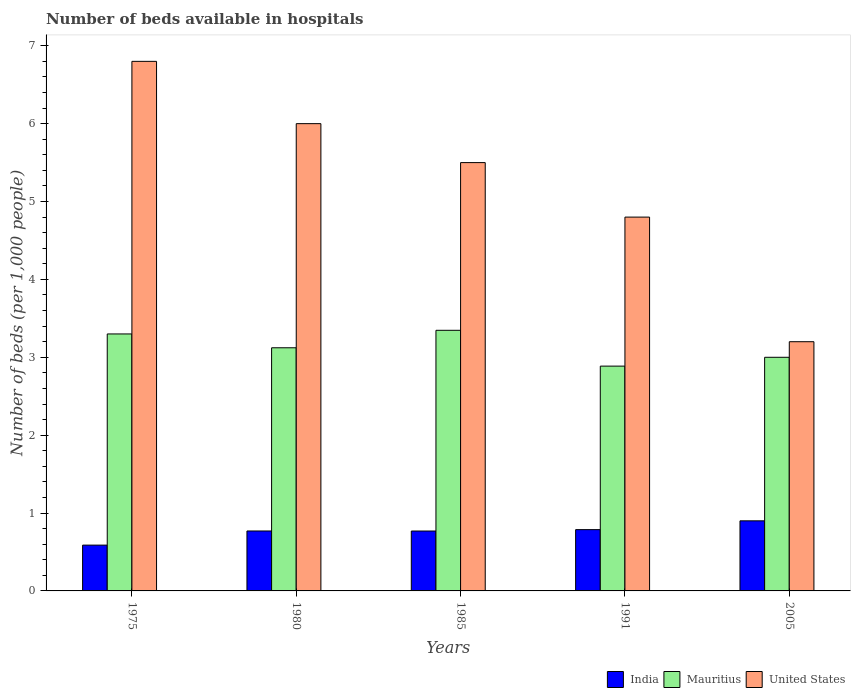How many different coloured bars are there?
Ensure brevity in your answer.  3. Are the number of bars on each tick of the X-axis equal?
Offer a terse response. Yes. How many bars are there on the 4th tick from the left?
Give a very brief answer. 3. How many bars are there on the 5th tick from the right?
Make the answer very short. 3. What is the label of the 1st group of bars from the left?
Provide a succinct answer. 1975. In how many cases, is the number of bars for a given year not equal to the number of legend labels?
Your answer should be compact. 0. Across all years, what is the maximum number of beds in the hospiatls of in United States?
Provide a short and direct response. 6.8. In which year was the number of beds in the hospiatls of in Mauritius maximum?
Ensure brevity in your answer.  1985. In which year was the number of beds in the hospiatls of in India minimum?
Your answer should be compact. 1975. What is the total number of beds in the hospiatls of in United States in the graph?
Offer a very short reply. 26.3. What is the difference between the number of beds in the hospiatls of in United States in 1985 and that in 1991?
Your response must be concise. 0.7. What is the difference between the number of beds in the hospiatls of in United States in 1991 and the number of beds in the hospiatls of in Mauritius in 1980?
Your response must be concise. 1.68. What is the average number of beds in the hospiatls of in India per year?
Keep it short and to the point. 0.76. In the year 1991, what is the difference between the number of beds in the hospiatls of in India and number of beds in the hospiatls of in Mauritius?
Provide a short and direct response. -2.1. What is the ratio of the number of beds in the hospiatls of in India in 1980 to that in 2005?
Give a very brief answer. 0.86. Is the number of beds in the hospiatls of in India in 1975 less than that in 2005?
Keep it short and to the point. Yes. Is the difference between the number of beds in the hospiatls of in India in 1991 and 2005 greater than the difference between the number of beds in the hospiatls of in Mauritius in 1991 and 2005?
Your response must be concise. Yes. What is the difference between the highest and the second highest number of beds in the hospiatls of in United States?
Your answer should be compact. 0.8. What is the difference between the highest and the lowest number of beds in the hospiatls of in India?
Keep it short and to the point. 0.31. In how many years, is the number of beds in the hospiatls of in India greater than the average number of beds in the hospiatls of in India taken over all years?
Your response must be concise. 4. What does the 3rd bar from the left in 1991 represents?
Provide a short and direct response. United States. What does the 2nd bar from the right in 1975 represents?
Provide a succinct answer. Mauritius. Is it the case that in every year, the sum of the number of beds in the hospiatls of in India and number of beds in the hospiatls of in Mauritius is greater than the number of beds in the hospiatls of in United States?
Your answer should be compact. No. How many bars are there?
Offer a very short reply. 15. What is the difference between two consecutive major ticks on the Y-axis?
Ensure brevity in your answer.  1. Where does the legend appear in the graph?
Offer a very short reply. Bottom right. How many legend labels are there?
Offer a terse response. 3. What is the title of the graph?
Your answer should be compact. Number of beds available in hospitals. Does "Guatemala" appear as one of the legend labels in the graph?
Provide a short and direct response. No. What is the label or title of the Y-axis?
Give a very brief answer. Number of beds (per 1,0 people). What is the Number of beds (per 1,000 people) of India in 1975?
Provide a succinct answer. 0.59. What is the Number of beds (per 1,000 people) in Mauritius in 1975?
Ensure brevity in your answer.  3.3. What is the Number of beds (per 1,000 people) in United States in 1975?
Your answer should be very brief. 6.8. What is the Number of beds (per 1,000 people) of India in 1980?
Make the answer very short. 0.77. What is the Number of beds (per 1,000 people) of Mauritius in 1980?
Offer a very short reply. 3.12. What is the Number of beds (per 1,000 people) in United States in 1980?
Your response must be concise. 6. What is the Number of beds (per 1,000 people) of India in 1985?
Keep it short and to the point. 0.77. What is the Number of beds (per 1,000 people) of Mauritius in 1985?
Make the answer very short. 3.35. What is the Number of beds (per 1,000 people) of United States in 1985?
Offer a very short reply. 5.5. What is the Number of beds (per 1,000 people) in India in 1991?
Ensure brevity in your answer.  0.79. What is the Number of beds (per 1,000 people) of Mauritius in 1991?
Your response must be concise. 2.89. What is the Number of beds (per 1,000 people) of United States in 1991?
Keep it short and to the point. 4.8. What is the Number of beds (per 1,000 people) in India in 2005?
Offer a terse response. 0.9. What is the Number of beds (per 1,000 people) in United States in 2005?
Your answer should be compact. 3.2. Across all years, what is the maximum Number of beds (per 1,000 people) of Mauritius?
Your response must be concise. 3.35. Across all years, what is the maximum Number of beds (per 1,000 people) of United States?
Your answer should be very brief. 6.8. Across all years, what is the minimum Number of beds (per 1,000 people) of India?
Offer a very short reply. 0.59. Across all years, what is the minimum Number of beds (per 1,000 people) of Mauritius?
Your answer should be very brief. 2.89. What is the total Number of beds (per 1,000 people) in India in the graph?
Keep it short and to the point. 3.81. What is the total Number of beds (per 1,000 people) in Mauritius in the graph?
Ensure brevity in your answer.  15.65. What is the total Number of beds (per 1,000 people) of United States in the graph?
Give a very brief answer. 26.3. What is the difference between the Number of beds (per 1,000 people) in India in 1975 and that in 1980?
Make the answer very short. -0.18. What is the difference between the Number of beds (per 1,000 people) in Mauritius in 1975 and that in 1980?
Ensure brevity in your answer.  0.18. What is the difference between the Number of beds (per 1,000 people) in India in 1975 and that in 1985?
Ensure brevity in your answer.  -0.18. What is the difference between the Number of beds (per 1,000 people) of Mauritius in 1975 and that in 1985?
Provide a succinct answer. -0.05. What is the difference between the Number of beds (per 1,000 people) of United States in 1975 and that in 1985?
Your response must be concise. 1.3. What is the difference between the Number of beds (per 1,000 people) of India in 1975 and that in 1991?
Your answer should be compact. -0.2. What is the difference between the Number of beds (per 1,000 people) of Mauritius in 1975 and that in 1991?
Provide a short and direct response. 0.41. What is the difference between the Number of beds (per 1,000 people) of India in 1975 and that in 2005?
Provide a succinct answer. -0.31. What is the difference between the Number of beds (per 1,000 people) in Mauritius in 1975 and that in 2005?
Offer a very short reply. 0.3. What is the difference between the Number of beds (per 1,000 people) of United States in 1975 and that in 2005?
Your answer should be very brief. 3.6. What is the difference between the Number of beds (per 1,000 people) of India in 1980 and that in 1985?
Your answer should be compact. 0. What is the difference between the Number of beds (per 1,000 people) of Mauritius in 1980 and that in 1985?
Your response must be concise. -0.22. What is the difference between the Number of beds (per 1,000 people) in United States in 1980 and that in 1985?
Your answer should be compact. 0.5. What is the difference between the Number of beds (per 1,000 people) of India in 1980 and that in 1991?
Provide a succinct answer. -0.02. What is the difference between the Number of beds (per 1,000 people) of Mauritius in 1980 and that in 1991?
Give a very brief answer. 0.24. What is the difference between the Number of beds (per 1,000 people) in United States in 1980 and that in 1991?
Keep it short and to the point. 1.2. What is the difference between the Number of beds (per 1,000 people) in India in 1980 and that in 2005?
Make the answer very short. -0.13. What is the difference between the Number of beds (per 1,000 people) in Mauritius in 1980 and that in 2005?
Give a very brief answer. 0.12. What is the difference between the Number of beds (per 1,000 people) in India in 1985 and that in 1991?
Ensure brevity in your answer.  -0.02. What is the difference between the Number of beds (per 1,000 people) in Mauritius in 1985 and that in 1991?
Provide a succinct answer. 0.46. What is the difference between the Number of beds (per 1,000 people) of United States in 1985 and that in 1991?
Offer a very short reply. 0.7. What is the difference between the Number of beds (per 1,000 people) of India in 1985 and that in 2005?
Offer a terse response. -0.13. What is the difference between the Number of beds (per 1,000 people) of Mauritius in 1985 and that in 2005?
Your answer should be very brief. 0.35. What is the difference between the Number of beds (per 1,000 people) in India in 1991 and that in 2005?
Offer a very short reply. -0.11. What is the difference between the Number of beds (per 1,000 people) of Mauritius in 1991 and that in 2005?
Keep it short and to the point. -0.11. What is the difference between the Number of beds (per 1,000 people) in United States in 1991 and that in 2005?
Ensure brevity in your answer.  1.6. What is the difference between the Number of beds (per 1,000 people) of India in 1975 and the Number of beds (per 1,000 people) of Mauritius in 1980?
Offer a terse response. -2.53. What is the difference between the Number of beds (per 1,000 people) of India in 1975 and the Number of beds (per 1,000 people) of United States in 1980?
Your response must be concise. -5.41. What is the difference between the Number of beds (per 1,000 people) in Mauritius in 1975 and the Number of beds (per 1,000 people) in United States in 1980?
Give a very brief answer. -2.7. What is the difference between the Number of beds (per 1,000 people) of India in 1975 and the Number of beds (per 1,000 people) of Mauritius in 1985?
Keep it short and to the point. -2.76. What is the difference between the Number of beds (per 1,000 people) of India in 1975 and the Number of beds (per 1,000 people) of United States in 1985?
Offer a very short reply. -4.91. What is the difference between the Number of beds (per 1,000 people) in Mauritius in 1975 and the Number of beds (per 1,000 people) in United States in 1985?
Make the answer very short. -2.2. What is the difference between the Number of beds (per 1,000 people) in India in 1975 and the Number of beds (per 1,000 people) in Mauritius in 1991?
Give a very brief answer. -2.3. What is the difference between the Number of beds (per 1,000 people) of India in 1975 and the Number of beds (per 1,000 people) of United States in 1991?
Your answer should be compact. -4.21. What is the difference between the Number of beds (per 1,000 people) of Mauritius in 1975 and the Number of beds (per 1,000 people) of United States in 1991?
Give a very brief answer. -1.5. What is the difference between the Number of beds (per 1,000 people) in India in 1975 and the Number of beds (per 1,000 people) in Mauritius in 2005?
Your answer should be very brief. -2.41. What is the difference between the Number of beds (per 1,000 people) in India in 1975 and the Number of beds (per 1,000 people) in United States in 2005?
Your response must be concise. -2.61. What is the difference between the Number of beds (per 1,000 people) in Mauritius in 1975 and the Number of beds (per 1,000 people) in United States in 2005?
Your answer should be compact. 0.1. What is the difference between the Number of beds (per 1,000 people) in India in 1980 and the Number of beds (per 1,000 people) in Mauritius in 1985?
Your answer should be compact. -2.58. What is the difference between the Number of beds (per 1,000 people) of India in 1980 and the Number of beds (per 1,000 people) of United States in 1985?
Your answer should be compact. -4.73. What is the difference between the Number of beds (per 1,000 people) of Mauritius in 1980 and the Number of beds (per 1,000 people) of United States in 1985?
Your response must be concise. -2.38. What is the difference between the Number of beds (per 1,000 people) in India in 1980 and the Number of beds (per 1,000 people) in Mauritius in 1991?
Give a very brief answer. -2.12. What is the difference between the Number of beds (per 1,000 people) in India in 1980 and the Number of beds (per 1,000 people) in United States in 1991?
Give a very brief answer. -4.03. What is the difference between the Number of beds (per 1,000 people) of Mauritius in 1980 and the Number of beds (per 1,000 people) of United States in 1991?
Ensure brevity in your answer.  -1.68. What is the difference between the Number of beds (per 1,000 people) in India in 1980 and the Number of beds (per 1,000 people) in Mauritius in 2005?
Give a very brief answer. -2.23. What is the difference between the Number of beds (per 1,000 people) of India in 1980 and the Number of beds (per 1,000 people) of United States in 2005?
Offer a very short reply. -2.43. What is the difference between the Number of beds (per 1,000 people) in Mauritius in 1980 and the Number of beds (per 1,000 people) in United States in 2005?
Provide a succinct answer. -0.08. What is the difference between the Number of beds (per 1,000 people) in India in 1985 and the Number of beds (per 1,000 people) in Mauritius in 1991?
Ensure brevity in your answer.  -2.12. What is the difference between the Number of beds (per 1,000 people) in India in 1985 and the Number of beds (per 1,000 people) in United States in 1991?
Your answer should be very brief. -4.03. What is the difference between the Number of beds (per 1,000 people) of Mauritius in 1985 and the Number of beds (per 1,000 people) of United States in 1991?
Keep it short and to the point. -1.45. What is the difference between the Number of beds (per 1,000 people) of India in 1985 and the Number of beds (per 1,000 people) of Mauritius in 2005?
Offer a very short reply. -2.23. What is the difference between the Number of beds (per 1,000 people) in India in 1985 and the Number of beds (per 1,000 people) in United States in 2005?
Provide a succinct answer. -2.43. What is the difference between the Number of beds (per 1,000 people) of Mauritius in 1985 and the Number of beds (per 1,000 people) of United States in 2005?
Keep it short and to the point. 0.15. What is the difference between the Number of beds (per 1,000 people) in India in 1991 and the Number of beds (per 1,000 people) in Mauritius in 2005?
Provide a short and direct response. -2.21. What is the difference between the Number of beds (per 1,000 people) in India in 1991 and the Number of beds (per 1,000 people) in United States in 2005?
Give a very brief answer. -2.41. What is the difference between the Number of beds (per 1,000 people) of Mauritius in 1991 and the Number of beds (per 1,000 people) of United States in 2005?
Ensure brevity in your answer.  -0.31. What is the average Number of beds (per 1,000 people) of India per year?
Keep it short and to the point. 0.76. What is the average Number of beds (per 1,000 people) of Mauritius per year?
Your answer should be very brief. 3.13. What is the average Number of beds (per 1,000 people) of United States per year?
Offer a terse response. 5.26. In the year 1975, what is the difference between the Number of beds (per 1,000 people) in India and Number of beds (per 1,000 people) in Mauritius?
Your answer should be very brief. -2.71. In the year 1975, what is the difference between the Number of beds (per 1,000 people) of India and Number of beds (per 1,000 people) of United States?
Give a very brief answer. -6.21. In the year 1975, what is the difference between the Number of beds (per 1,000 people) of Mauritius and Number of beds (per 1,000 people) of United States?
Give a very brief answer. -3.5. In the year 1980, what is the difference between the Number of beds (per 1,000 people) of India and Number of beds (per 1,000 people) of Mauritius?
Offer a terse response. -2.35. In the year 1980, what is the difference between the Number of beds (per 1,000 people) in India and Number of beds (per 1,000 people) in United States?
Your response must be concise. -5.23. In the year 1980, what is the difference between the Number of beds (per 1,000 people) of Mauritius and Number of beds (per 1,000 people) of United States?
Your answer should be very brief. -2.88. In the year 1985, what is the difference between the Number of beds (per 1,000 people) in India and Number of beds (per 1,000 people) in Mauritius?
Provide a short and direct response. -2.58. In the year 1985, what is the difference between the Number of beds (per 1,000 people) in India and Number of beds (per 1,000 people) in United States?
Offer a very short reply. -4.73. In the year 1985, what is the difference between the Number of beds (per 1,000 people) in Mauritius and Number of beds (per 1,000 people) in United States?
Offer a terse response. -2.15. In the year 1991, what is the difference between the Number of beds (per 1,000 people) of India and Number of beds (per 1,000 people) of Mauritius?
Make the answer very short. -2.1. In the year 1991, what is the difference between the Number of beds (per 1,000 people) of India and Number of beds (per 1,000 people) of United States?
Provide a succinct answer. -4.01. In the year 1991, what is the difference between the Number of beds (per 1,000 people) in Mauritius and Number of beds (per 1,000 people) in United States?
Provide a short and direct response. -1.91. In the year 2005, what is the difference between the Number of beds (per 1,000 people) of Mauritius and Number of beds (per 1,000 people) of United States?
Make the answer very short. -0.2. What is the ratio of the Number of beds (per 1,000 people) in India in 1975 to that in 1980?
Make the answer very short. 0.76. What is the ratio of the Number of beds (per 1,000 people) of Mauritius in 1975 to that in 1980?
Provide a succinct answer. 1.06. What is the ratio of the Number of beds (per 1,000 people) in United States in 1975 to that in 1980?
Your answer should be very brief. 1.13. What is the ratio of the Number of beds (per 1,000 people) in India in 1975 to that in 1985?
Give a very brief answer. 0.76. What is the ratio of the Number of beds (per 1,000 people) in Mauritius in 1975 to that in 1985?
Your answer should be very brief. 0.99. What is the ratio of the Number of beds (per 1,000 people) of United States in 1975 to that in 1985?
Make the answer very short. 1.24. What is the ratio of the Number of beds (per 1,000 people) in India in 1975 to that in 1991?
Provide a short and direct response. 0.75. What is the ratio of the Number of beds (per 1,000 people) in Mauritius in 1975 to that in 1991?
Make the answer very short. 1.14. What is the ratio of the Number of beds (per 1,000 people) in United States in 1975 to that in 1991?
Keep it short and to the point. 1.42. What is the ratio of the Number of beds (per 1,000 people) in India in 1975 to that in 2005?
Give a very brief answer. 0.65. What is the ratio of the Number of beds (per 1,000 people) of Mauritius in 1975 to that in 2005?
Make the answer very short. 1.1. What is the ratio of the Number of beds (per 1,000 people) in United States in 1975 to that in 2005?
Your answer should be compact. 2.12. What is the ratio of the Number of beds (per 1,000 people) of Mauritius in 1980 to that in 1985?
Your response must be concise. 0.93. What is the ratio of the Number of beds (per 1,000 people) of Mauritius in 1980 to that in 1991?
Offer a very short reply. 1.08. What is the ratio of the Number of beds (per 1,000 people) in United States in 1980 to that in 1991?
Provide a short and direct response. 1.25. What is the ratio of the Number of beds (per 1,000 people) in India in 1980 to that in 2005?
Offer a very short reply. 0.86. What is the ratio of the Number of beds (per 1,000 people) in Mauritius in 1980 to that in 2005?
Offer a very short reply. 1.04. What is the ratio of the Number of beds (per 1,000 people) in United States in 1980 to that in 2005?
Give a very brief answer. 1.88. What is the ratio of the Number of beds (per 1,000 people) in India in 1985 to that in 1991?
Give a very brief answer. 0.98. What is the ratio of the Number of beds (per 1,000 people) in Mauritius in 1985 to that in 1991?
Make the answer very short. 1.16. What is the ratio of the Number of beds (per 1,000 people) of United States in 1985 to that in 1991?
Provide a succinct answer. 1.15. What is the ratio of the Number of beds (per 1,000 people) in India in 1985 to that in 2005?
Keep it short and to the point. 0.85. What is the ratio of the Number of beds (per 1,000 people) in Mauritius in 1985 to that in 2005?
Provide a succinct answer. 1.12. What is the ratio of the Number of beds (per 1,000 people) of United States in 1985 to that in 2005?
Provide a short and direct response. 1.72. What is the ratio of the Number of beds (per 1,000 people) of India in 1991 to that in 2005?
Keep it short and to the point. 0.87. What is the ratio of the Number of beds (per 1,000 people) of Mauritius in 1991 to that in 2005?
Your response must be concise. 0.96. What is the difference between the highest and the second highest Number of beds (per 1,000 people) of India?
Provide a succinct answer. 0.11. What is the difference between the highest and the second highest Number of beds (per 1,000 people) in Mauritius?
Your response must be concise. 0.05. What is the difference between the highest and the lowest Number of beds (per 1,000 people) of India?
Give a very brief answer. 0.31. What is the difference between the highest and the lowest Number of beds (per 1,000 people) of Mauritius?
Your response must be concise. 0.46. 